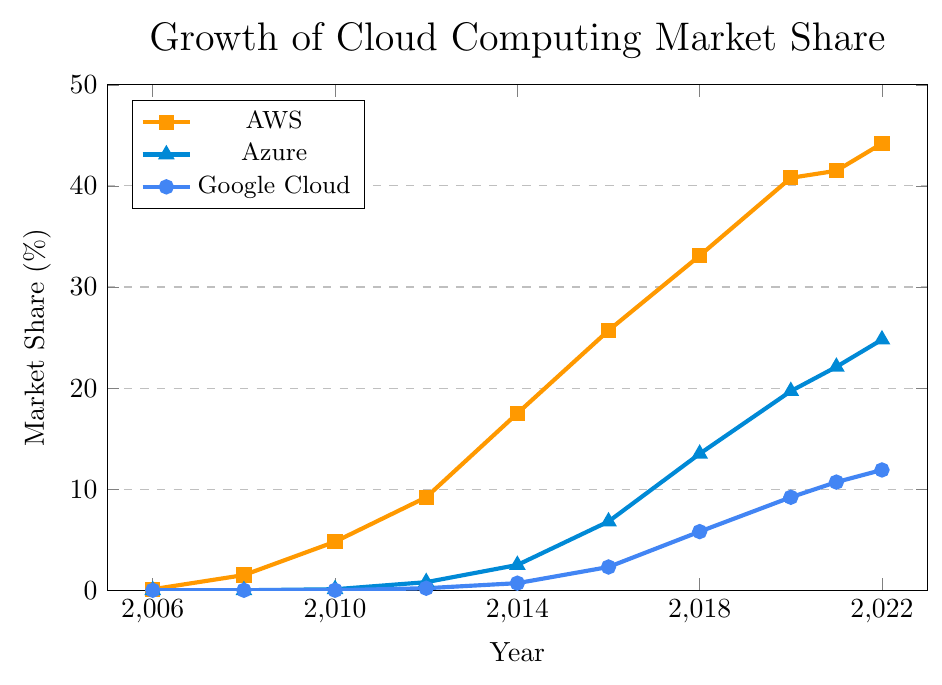What was AWS's market share in 2020? By looking at the figure, find the point corresponding to 2020 on the AWS line and note the market share value.
Answer: 40.8% Which cloud provider had the lowest market share in 2014? Compare the market share values of AWS, Azure, and Google Cloud for 2014 from the chart.
Answer: Google Cloud How much did Azure's market share increase from 2018 to 2022? Find Azure's market share values for 2018 and 2022, then subtract the 2018 value from the 2022 value (24.8% - 13.5%).
Answer: 11.3% In which year did AWS have a market share greater than 40% for the first time? Check the AWS line for the first point where the market share exceeds 40%, which happens in 2020.
Answer: 2020 By how much did Google Cloud's market share grow from 2012 to 2016? Find Google Cloud's market share values for 2012 and 2016, then subtract the 2012 value from the 2016 value (2.3% - 0.2%).
Answer: 2.1% Which provider had the fastest growth in market share from 2016 to 2018? By calculating the growth rate (difference in market share) for each provider between 2016 and 2018, determine the provider with the highest difference. AWS: 33.1 - 25.7 = 7.4, Azure: 13.5 - 6.8 = 6.7, Google Cloud: 5.8 - 2.3 = 3.5. AWS has the highest growth of 7.4%.
Answer: AWS What is the difference in market share between Azure and Google Cloud in 2021? Subtract Google Cloud's market share in 2021 from Azure's market share in 2021 (22.1% - 10.7%).
Answer: 11.4% Between AWS, Azure, and Google Cloud, which provider had the most consistent market share growth from 2006 to 2022 based on the visual trend? By observing the graph, determine which provider's line has the most linear or smooth upward trend.
Answer: AWS 